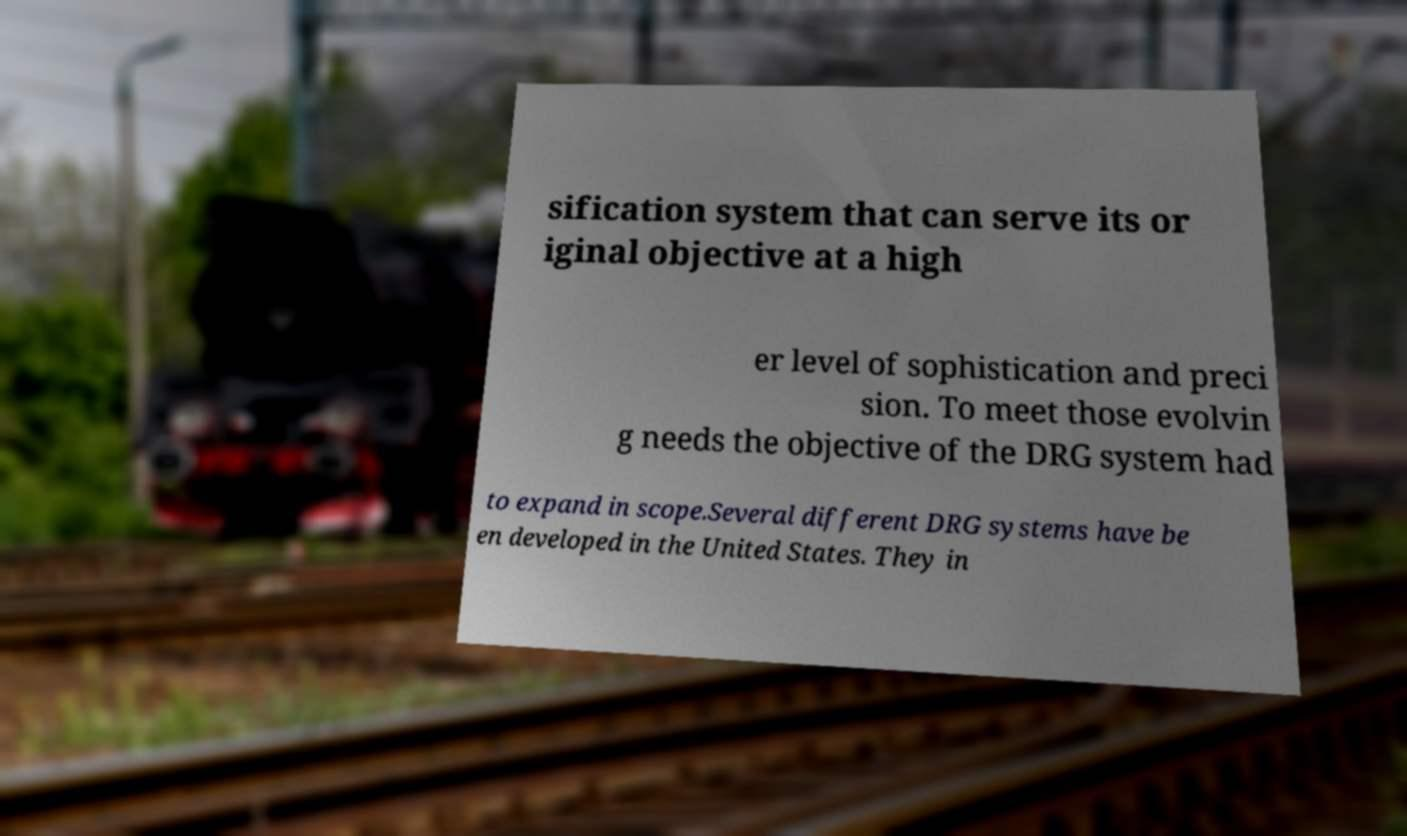For documentation purposes, I need the text within this image transcribed. Could you provide that? sification system that can serve its or iginal objective at a high er level of sophistication and preci sion. To meet those evolvin g needs the objective of the DRG system had to expand in scope.Several different DRG systems have be en developed in the United States. They in 